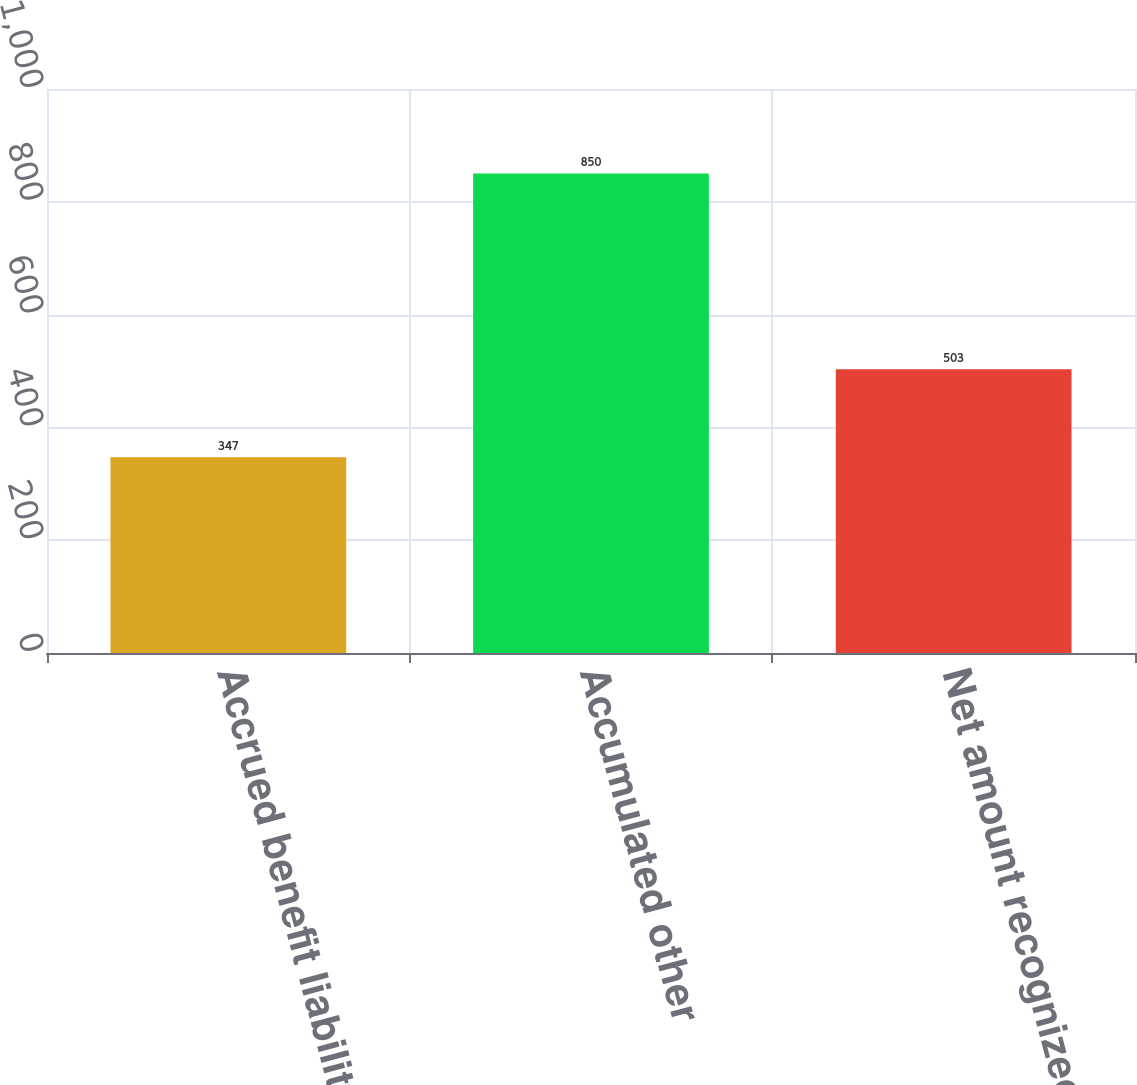Convert chart to OTSL. <chart><loc_0><loc_0><loc_500><loc_500><bar_chart><fcel>Accrued benefit liability<fcel>Accumulated other<fcel>Net amount recognized<nl><fcel>347<fcel>850<fcel>503<nl></chart> 